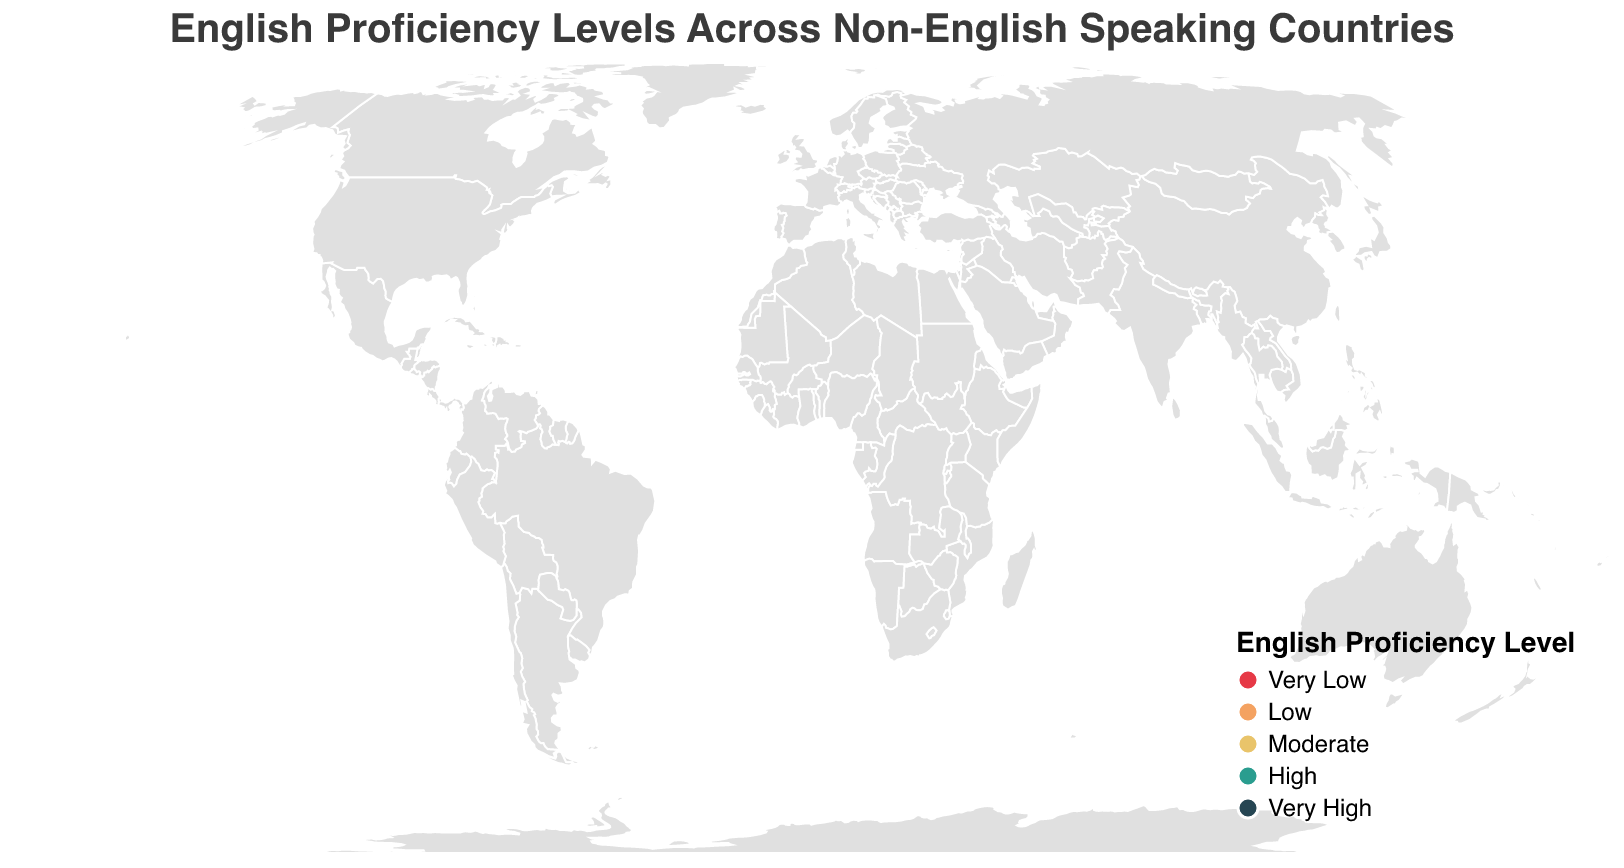what is the title of the plot? The title is shown at the top of the plot, reading "English Proficiency Levels Across Non-English Speaking Countries".
Answer: English Proficiency Levels Across Non-English Speaking Countries which countries have "Very High" English proficiency? The "Very High" proficiency countries are color-coded with the darkest shade on the plot. These countries include the Netherlands, Sweden, Denmark, and Norway.
Answer: Netherlands, Sweden, Denmark, Norway how many countries are categorized with "Low" English proficiency? Countries with "Low" proficiency are identified by a specific color on the plot (the second lightest shade). By counting these countries, we see there are four: China, Japan, Brazil, and Mexico.
Answer: 4 is there a higher number of countries categorized with "High" or "Moderate" English proficiency? Count the countries for each category by identifying their colors on the plot: "High" (5 countries: Singapore, Germany, Belgium, Austria, Poland, Portugal) and "Moderate" (4 countries: France, Spain, Italy, Russia). There are more "High" proficiency countries.
Answer: High which region has the most notable concentration of "Very High" English proficiency countries? By observing the plot, the concentration of "Very High" proficiency (darkest shade) is most notable in the region of Northern Europe, including the Netherlands, Sweden, Denmark, and Norway.
Answer: Northern Europe which country in Asia is closest to having "Very High" English proficiency? The plot colors Singapore in a lighter shade that represents "High" proficiency, making it the closest Asian country to having "Very High" proficiency.
Answer: Singapore how many countries are represented in the plot? By counting the different country entries in the plot, we find there are 20 countries represented.
Answer: 20 compare the English proficiency levels of France and Brazil France is categorized under "Moderate" proficiency, while Brazil is categorized under "Low" proficiency, as indicated by their respective colors.
Answer: France has higher proficiency than Brazil what is the color representation for "Moderate" English proficiency in the plot? The plot uses a specific shade to represent "Moderate" proficiency, which is a yellowish color.
Answer: Yellowish color which two countries have the lowest English proficiency in the Middle East region? The plot indicates that Saudi Arabia is in the "Very Low" category. No other Middle Eastern countries are represented, so only Saudi Arabia appears.
Answer: Saudi Arabia 